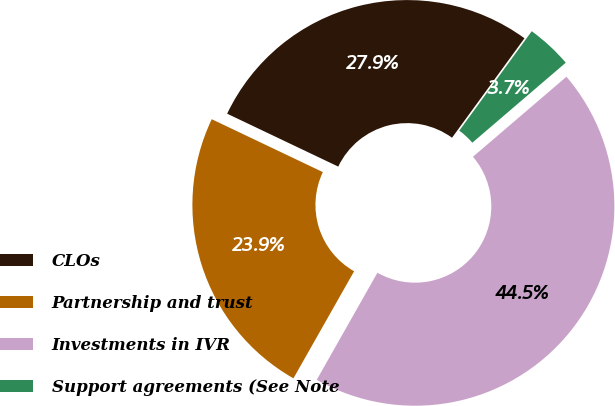Convert chart to OTSL. <chart><loc_0><loc_0><loc_500><loc_500><pie_chart><fcel>CLOs<fcel>Partnership and trust<fcel>Investments in IVR<fcel>Support agreements (See Note<nl><fcel>27.95%<fcel>23.87%<fcel>44.48%<fcel>3.71%<nl></chart> 